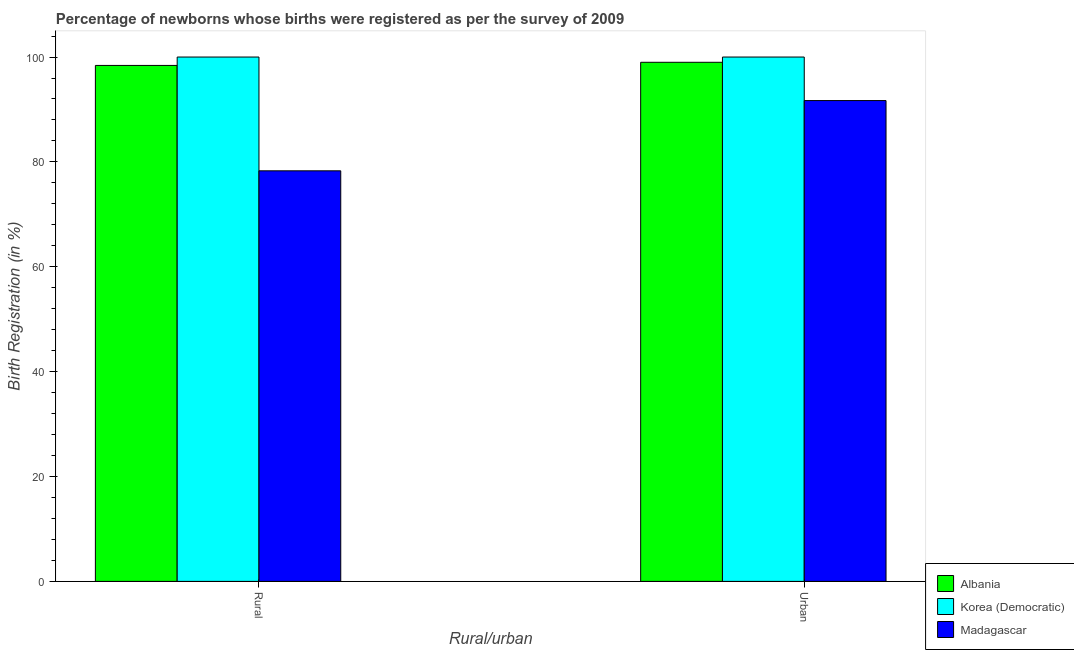Are the number of bars per tick equal to the number of legend labels?
Your response must be concise. Yes. Are the number of bars on each tick of the X-axis equal?
Offer a very short reply. Yes. How many bars are there on the 2nd tick from the left?
Offer a terse response. 3. How many bars are there on the 2nd tick from the right?
Your response must be concise. 3. What is the label of the 1st group of bars from the left?
Offer a very short reply. Rural. Across all countries, what is the maximum rural birth registration?
Keep it short and to the point. 100. Across all countries, what is the minimum urban birth registration?
Ensure brevity in your answer.  91.7. In which country was the rural birth registration maximum?
Ensure brevity in your answer.  Korea (Democratic). In which country was the urban birth registration minimum?
Your response must be concise. Madagascar. What is the total urban birth registration in the graph?
Keep it short and to the point. 290.7. What is the difference between the urban birth registration in Albania and that in Madagascar?
Offer a terse response. 7.3. What is the average rural birth registration per country?
Your answer should be very brief. 92.23. What is the ratio of the urban birth registration in Korea (Democratic) to that in Albania?
Offer a very short reply. 1.01. Is the rural birth registration in Madagascar less than that in Albania?
Offer a very short reply. Yes. In how many countries, is the urban birth registration greater than the average urban birth registration taken over all countries?
Provide a succinct answer. 2. What does the 1st bar from the left in Rural represents?
Give a very brief answer. Albania. What does the 3rd bar from the right in Urban represents?
Provide a short and direct response. Albania. How many bars are there?
Offer a terse response. 6. How many countries are there in the graph?
Ensure brevity in your answer.  3. What is the difference between two consecutive major ticks on the Y-axis?
Keep it short and to the point. 20. Does the graph contain grids?
Keep it short and to the point. No. How many legend labels are there?
Provide a succinct answer. 3. What is the title of the graph?
Your answer should be compact. Percentage of newborns whose births were registered as per the survey of 2009. What is the label or title of the X-axis?
Your answer should be very brief. Rural/urban. What is the label or title of the Y-axis?
Your answer should be very brief. Birth Registration (in %). What is the Birth Registration (in %) of Albania in Rural?
Keep it short and to the point. 98.4. What is the Birth Registration (in %) of Korea (Democratic) in Rural?
Give a very brief answer. 100. What is the Birth Registration (in %) in Madagascar in Rural?
Ensure brevity in your answer.  78.3. What is the Birth Registration (in %) in Albania in Urban?
Your answer should be compact. 99. What is the Birth Registration (in %) of Madagascar in Urban?
Offer a terse response. 91.7. Across all Rural/urban, what is the maximum Birth Registration (in %) of Korea (Democratic)?
Keep it short and to the point. 100. Across all Rural/urban, what is the maximum Birth Registration (in %) of Madagascar?
Ensure brevity in your answer.  91.7. Across all Rural/urban, what is the minimum Birth Registration (in %) of Albania?
Offer a terse response. 98.4. Across all Rural/urban, what is the minimum Birth Registration (in %) in Madagascar?
Your response must be concise. 78.3. What is the total Birth Registration (in %) of Albania in the graph?
Provide a succinct answer. 197.4. What is the total Birth Registration (in %) of Korea (Democratic) in the graph?
Your answer should be compact. 200. What is the total Birth Registration (in %) of Madagascar in the graph?
Provide a succinct answer. 170. What is the difference between the Birth Registration (in %) in Albania in Rural and that in Urban?
Make the answer very short. -0.6. What is the difference between the Birth Registration (in %) of Korea (Democratic) in Rural and that in Urban?
Keep it short and to the point. 0. What is the difference between the Birth Registration (in %) in Korea (Democratic) in Rural and the Birth Registration (in %) in Madagascar in Urban?
Keep it short and to the point. 8.3. What is the average Birth Registration (in %) in Albania per Rural/urban?
Provide a short and direct response. 98.7. What is the average Birth Registration (in %) of Korea (Democratic) per Rural/urban?
Provide a succinct answer. 100. What is the difference between the Birth Registration (in %) in Albania and Birth Registration (in %) in Korea (Democratic) in Rural?
Your answer should be very brief. -1.6. What is the difference between the Birth Registration (in %) in Albania and Birth Registration (in %) in Madagascar in Rural?
Your answer should be very brief. 20.1. What is the difference between the Birth Registration (in %) of Korea (Democratic) and Birth Registration (in %) of Madagascar in Rural?
Your answer should be very brief. 21.7. What is the difference between the Birth Registration (in %) in Albania and Birth Registration (in %) in Korea (Democratic) in Urban?
Give a very brief answer. -1. What is the difference between the Birth Registration (in %) of Albania and Birth Registration (in %) of Madagascar in Urban?
Provide a succinct answer. 7.3. What is the difference between the Birth Registration (in %) of Korea (Democratic) and Birth Registration (in %) of Madagascar in Urban?
Ensure brevity in your answer.  8.3. What is the ratio of the Birth Registration (in %) in Korea (Democratic) in Rural to that in Urban?
Your answer should be compact. 1. What is the ratio of the Birth Registration (in %) of Madagascar in Rural to that in Urban?
Provide a succinct answer. 0.85. What is the difference between the highest and the lowest Birth Registration (in %) of Korea (Democratic)?
Your answer should be compact. 0. What is the difference between the highest and the lowest Birth Registration (in %) of Madagascar?
Your answer should be very brief. 13.4. 